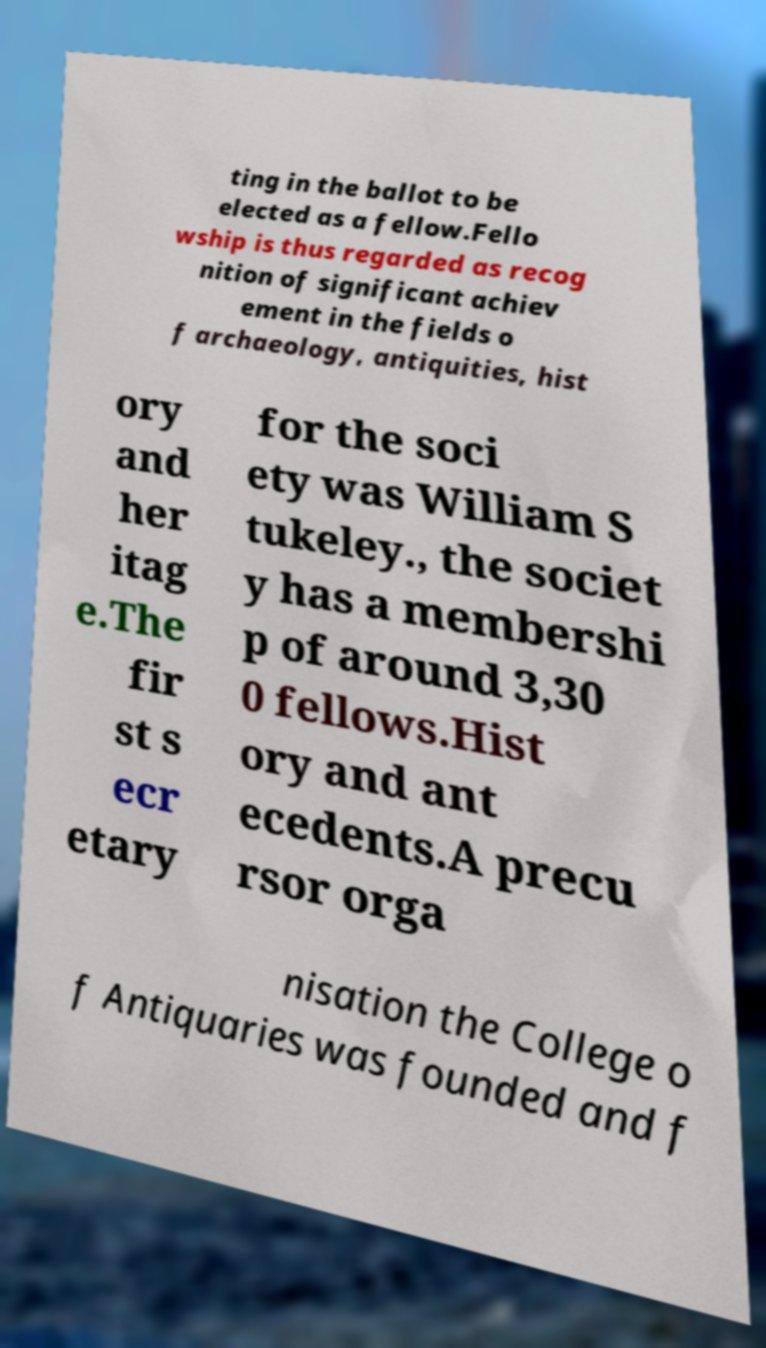Could you assist in decoding the text presented in this image and type it out clearly? ting in the ballot to be elected as a fellow.Fello wship is thus regarded as recog nition of significant achiev ement in the fields o f archaeology, antiquities, hist ory and her itag e.The fir st s ecr etary for the soci ety was William S tukeley., the societ y has a membershi p of around 3,30 0 fellows.Hist ory and ant ecedents.A precu rsor orga nisation the College o f Antiquaries was founded and f 